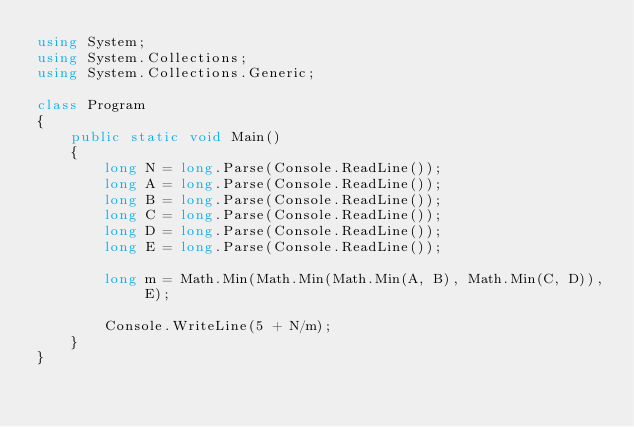<code> <loc_0><loc_0><loc_500><loc_500><_C#_>using System;
using System.Collections;
using System.Collections.Generic;

class Program
{
    public static void Main()
    {
        long N = long.Parse(Console.ReadLine());
        long A = long.Parse(Console.ReadLine());
        long B = long.Parse(Console.ReadLine());
        long C = long.Parse(Console.ReadLine());
        long D = long.Parse(Console.ReadLine());
        long E = long.Parse(Console.ReadLine());

        long m = Math.Min(Math.Min(Math.Min(A, B), Math.Min(C, D)), E);

        Console.WriteLine(5 + N/m);
    }
}</code> 